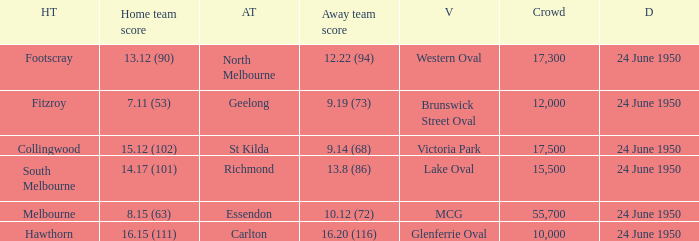When was the game where the away team had a score of 13.8 (86)? 24 June 1950. 